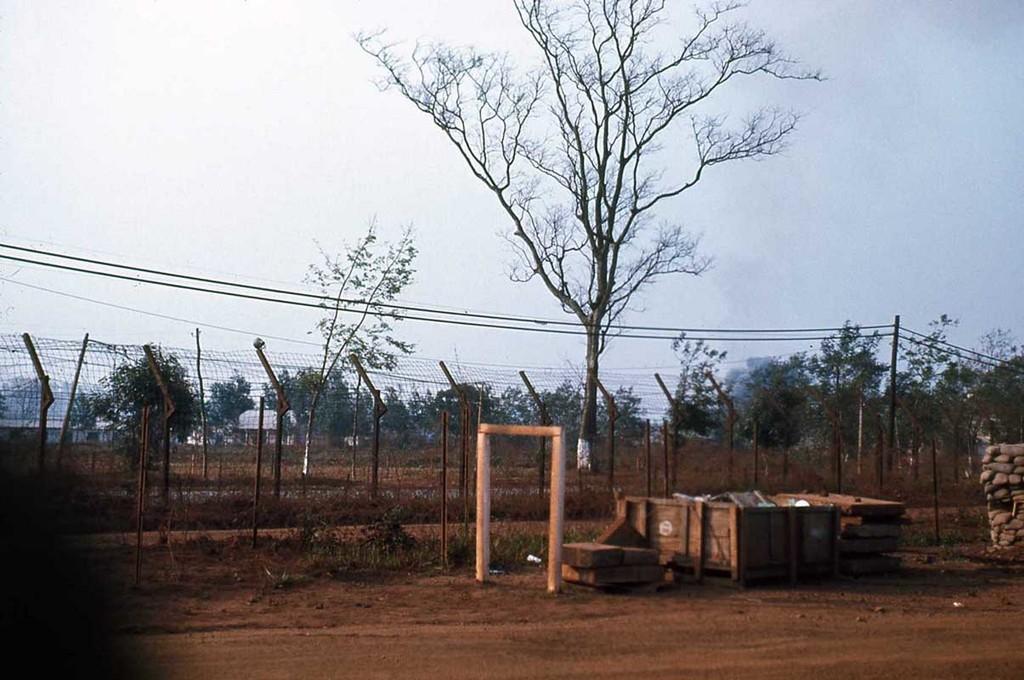Can you describe this image briefly? In this image we can see a container placed on the ground. In the center of the image we can see a fence, a group of trees, pole with cables. To the right side of the image we can see a stone wall and some wood pieces are placed on the ground. In the background, we can see the sky. 